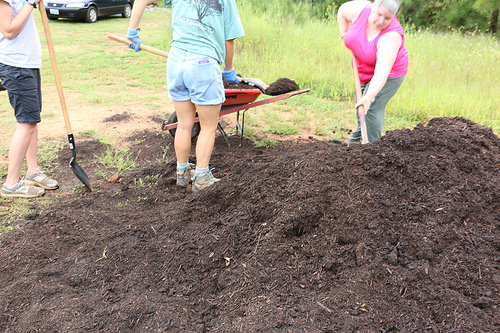<image>
Is the woman behind the shovel? No. The woman is not behind the shovel. From this viewpoint, the woman appears to be positioned elsewhere in the scene. 